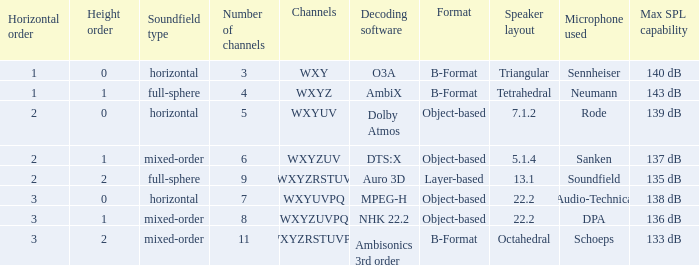If the channels are wxyzrstuvpq, what is the horizontal arrangement? 3.0. I'm looking to parse the entire table for insights. Could you assist me with that? {'header': ['Horizontal order', 'Height order', 'Soundfield type', 'Number of channels', 'Channels', 'Decoding software', 'Format', 'Speaker layout', 'Microphone used', 'Max SPL capability'], 'rows': [['1', '0', 'horizontal', '3', 'WXY', 'O3A', 'B-Format', 'Triangular', 'Sennheiser', '140 dB'], ['1', '1', 'full-sphere', '4', 'WXYZ', 'AmbiX', 'B-Format', 'Tetrahedral', 'Neumann', '143 dB'], ['2', '0', 'horizontal', '5', 'WXYUV', 'Dolby Atmos', 'Object-based', '7.1.2', 'Rode', '139 dB'], ['2', '1', 'mixed-order', '6', 'WXYZUV', 'DTS:X', 'Object-based', '5.1.4', 'Sanken', '137 dB'], ['2', '2', 'full-sphere', '9', 'WXYZRSTUV', 'Auro 3D', 'Layer-based', '13.1', 'Soundfield', '135 dB'], ['3', '0', 'horizontal', '7', 'WXYUVPQ', 'MPEG-H', 'Object-based', '22.2', 'Audio-Technica', '138 dB'], ['3', '1', 'mixed-order', '8', 'WXYZUVPQ', 'NHK 22.2', 'Object-based', '22.2', 'DPA', '136 dB'], ['3', '2', 'mixed-order', '11', 'WXYZRSTUVPQ', 'Ambisonics 3rd order', 'B-Format', 'Octahedral', 'Schoeps', '133 dB']]} 